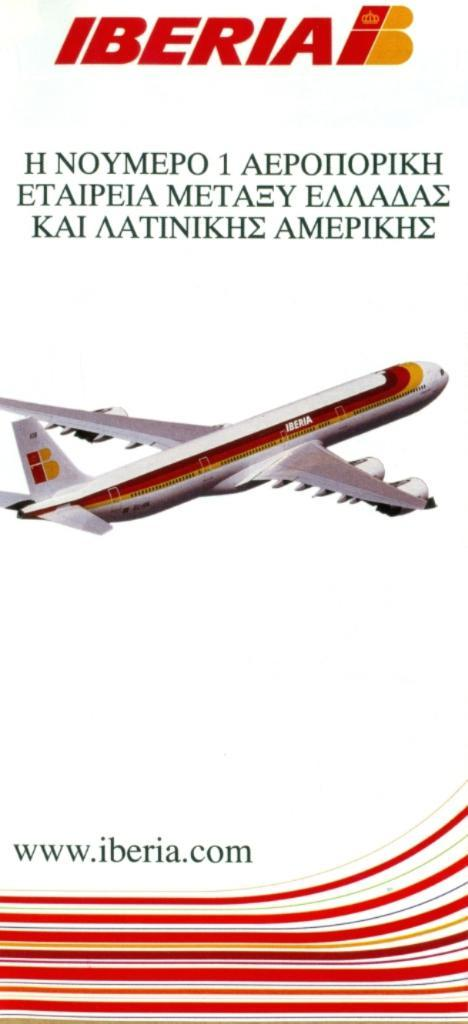<image>
Write a terse but informative summary of the picture. An advertisement in the Greek language that shows an Airplane with the IBERIA logo. 